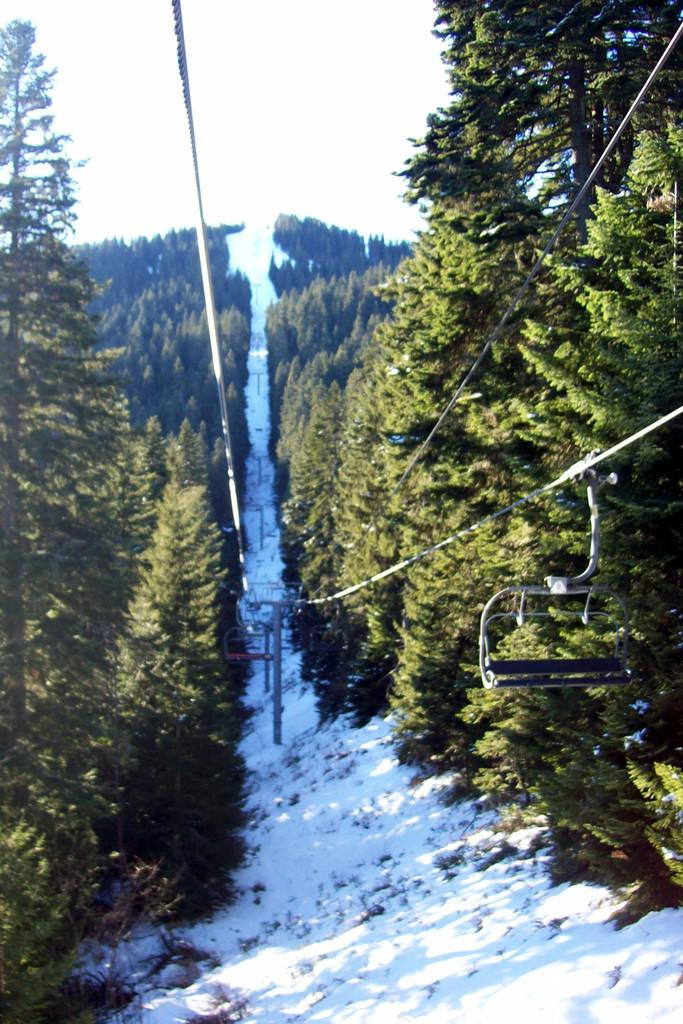What type of vegetation can be seen in the image? There are trees in the image. What is located between the trees? There is a path between the trees. What objects are present in the image that might be used for support or guidance? There are poles in the image. What else can be seen in the image that is related to the poles? There are ropes in the image. What is the weather like in the image? There is snow visible in the image, indicating a cold or wintry environment. What is visible in the background of the image? The sky is visible in the image. Where is the sister located in the image? There is no sister present in the image. What type of dolls can be seen playing near the airport in the image? There is no airport or dolls present in the image. 